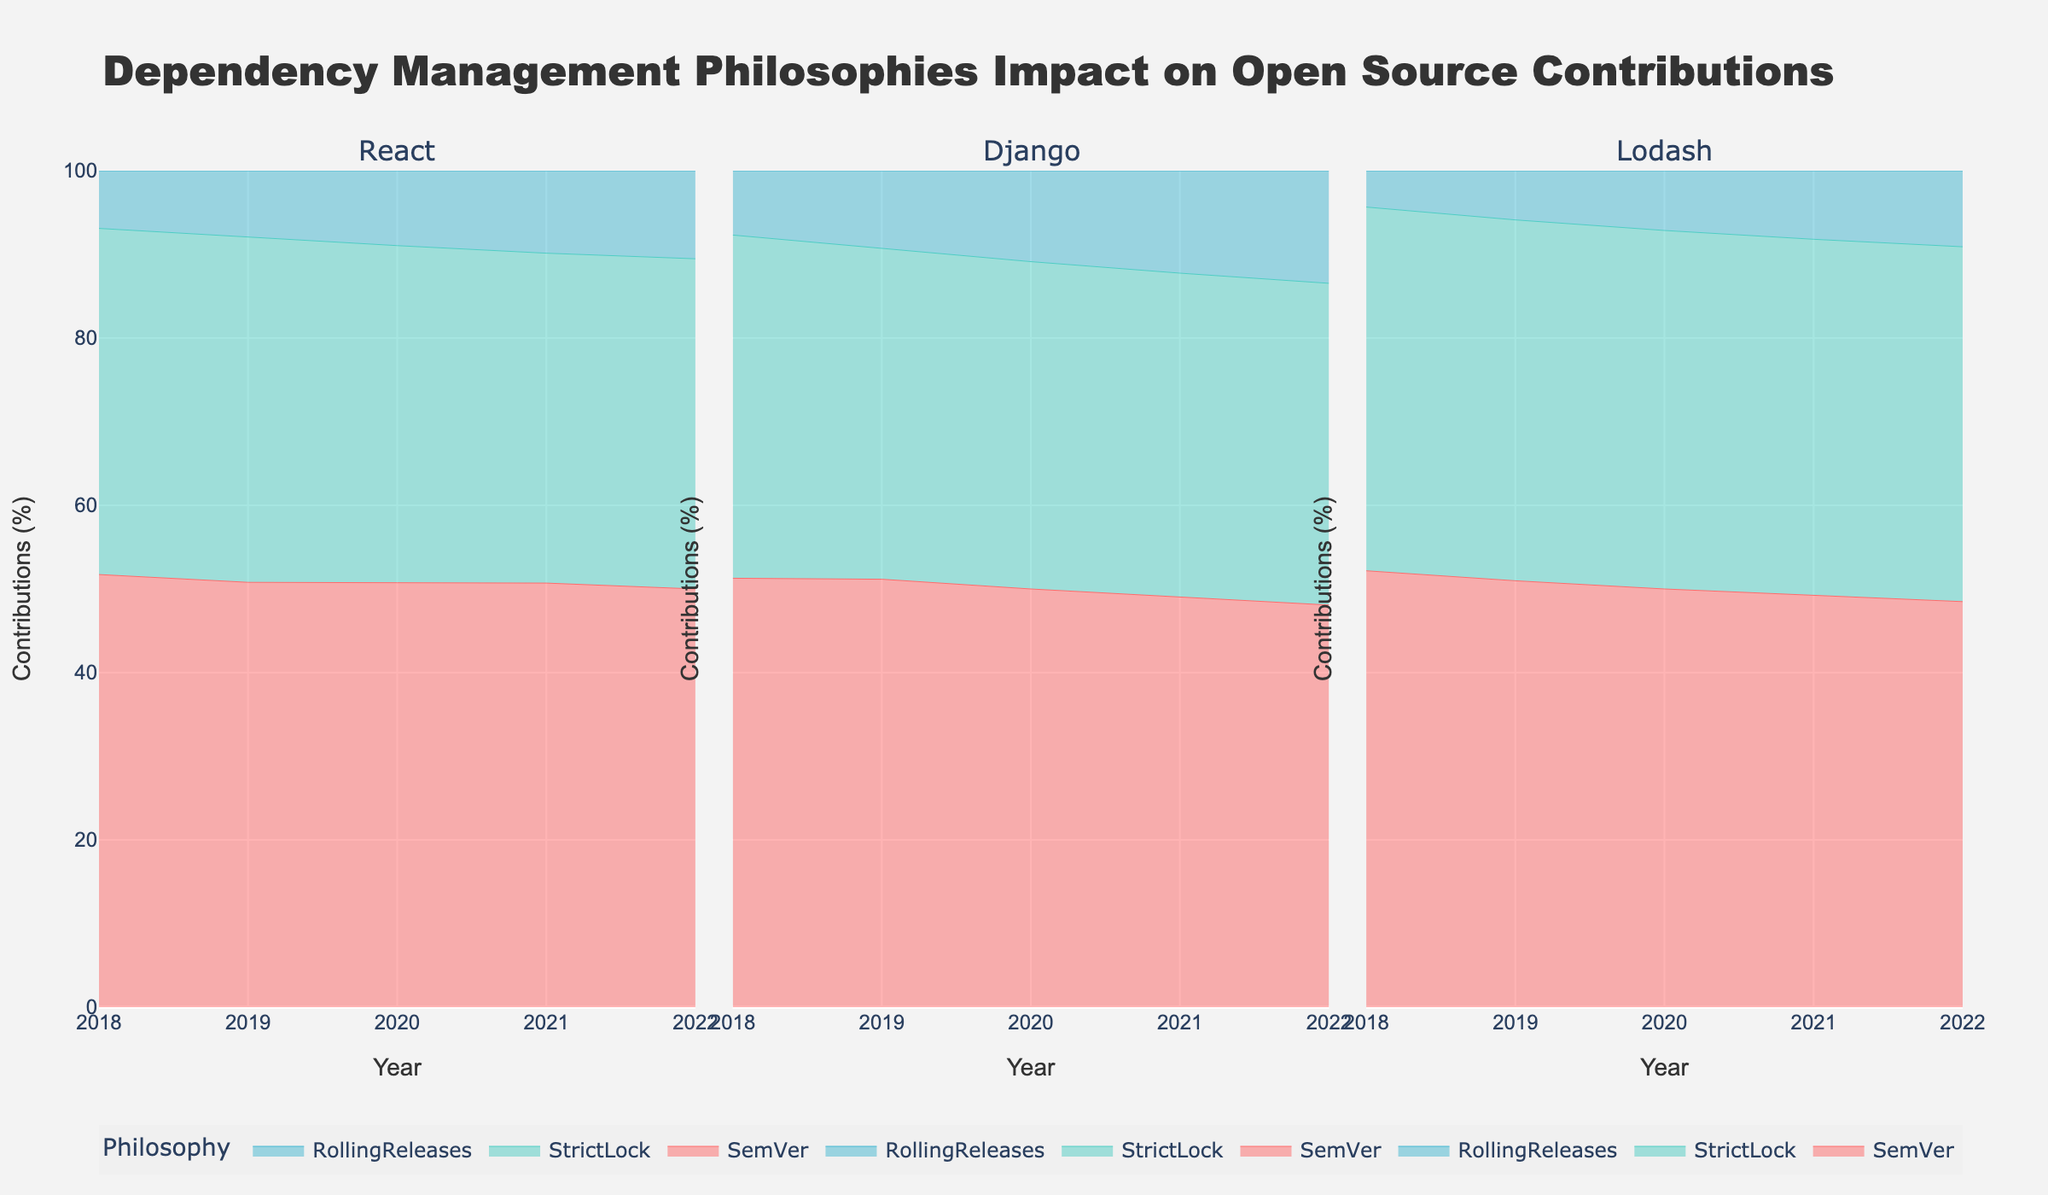What is the title of the chart? The title is at the top of the figure, specifying the contents and focus of the chart.
Answer: Dependency Management Philosophies Impact on Open Source Contributions Which dependency management philosophy has the highest percentage of contributions across all years for the React library? By observing the React subplot, the area for SemVer consistently occupies the largest portion throughout all years.
Answer: SemVer How did the contributions percentage of the RollingReleases philosophy change for the Django library from 2018 to 2022? Observe the area changes corresponding to RollingReleases for Django from 2018 to 2022; it increases gradually.
Answer: Increased Which library shows a more significant shift towards the StrictLock philosophy over the observed years? Compare the area changes for StrictLock across all libraries; focus on the proportion shift over the years. Django shows a notable increase in StrictLock areas.
Answer: Django What color represents the SemVer philosophy? Look at the legend and identify the color corresponding to the SemVer label.
Answer: Red By visually comparing the three libraries, which one has the smallest percentage of contributions from RollingReleases in 2022? Examine the subplots for the year 2022, and compare the areas for RollingReleases among React, Django, and Lodash. Lodash shows the smallest area.
Answer: Lodash How does the percentage contribution of the StrictLock philosophy for Lodash change from 2018 to 2022? Observe the area representing StrictLock in the Lodash subplot; it incrementally increases each year.
Answer: Increases Between 2018 and 2022, which philosophy showed the most consistent contribution percentage for Django? Analyze the areas for each philosophy in the Django subplot, and determine which maintains a relatively stable size. SemVer remains relatively stable.
Answer: SemVer Which library shows the highest overall contributions for SemVer in 2022? Compare the areas representing SemVer for each library in 2022. React shows the largest area.
Answer: React Compare the overall trends of contributions for RollingReleases in React and Lodash libraries from 2018 to 2022. What differences do you notice? Both subplots should be examined together; React increases gradually while Lodash grows slowly and consistently remains the smallest. React has a more notable increase.
Answer: React increases more noticeably 